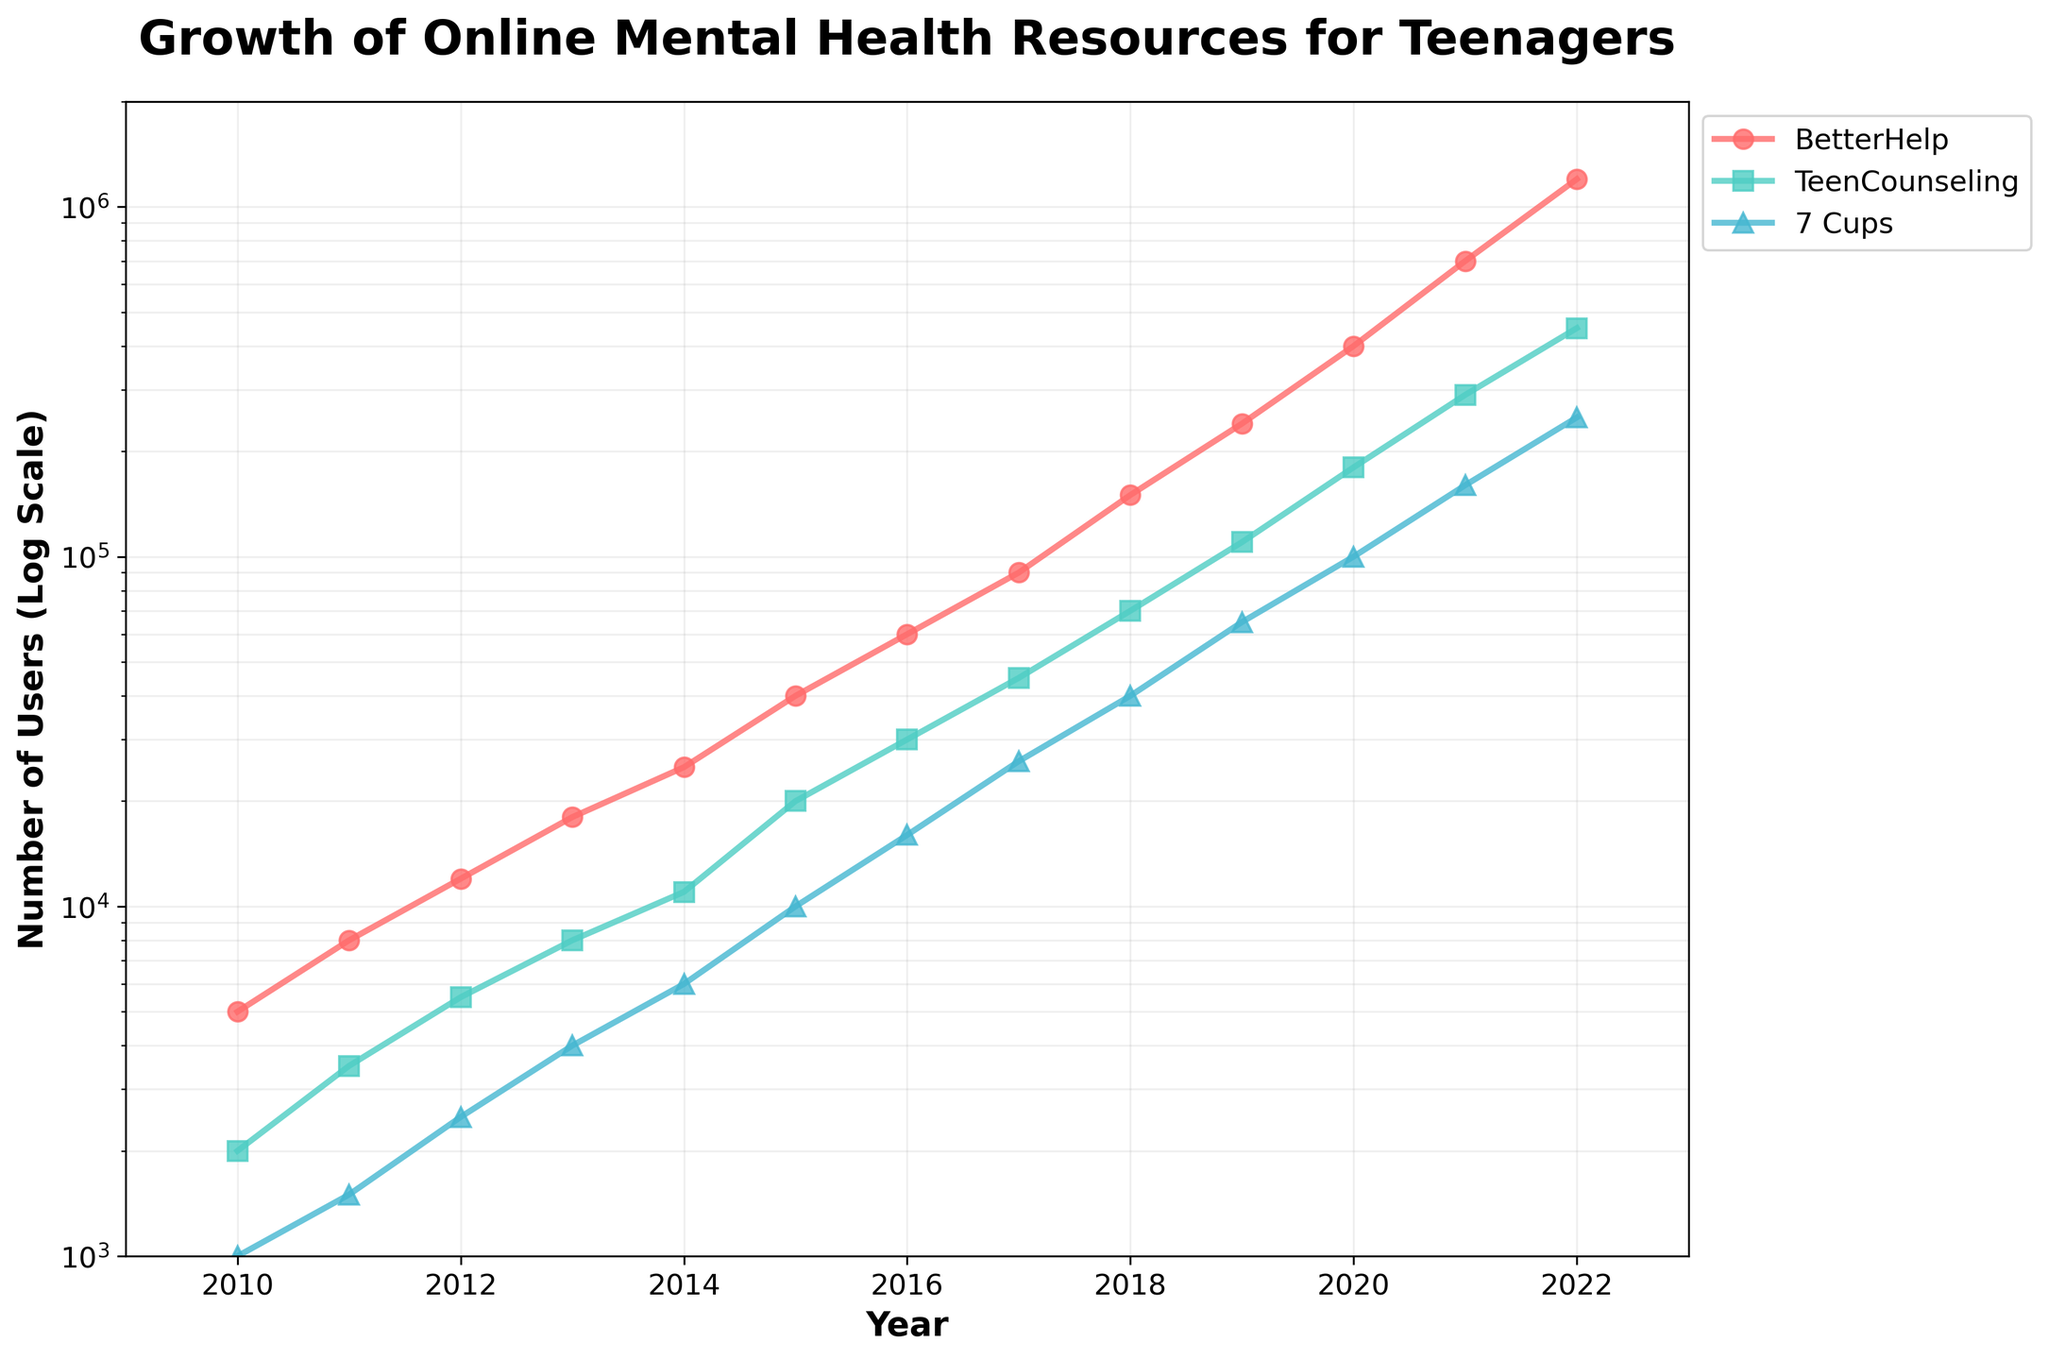What is the title of the plot? The title is located at the top of the figure. It provides a clear description of what the plot shows.
Answer: Growth of Online Mental Health Resources for Teenagers What is the y-axis scale used in the plot? Observing the y-axis, it is apparent that the values aren't evenly spaced. Instead, they increase exponentially, indicating a logarithmic scale.
Answer: Logarithmic scale Which resource had the greatest number of users in 2022? Locate the data points for 2022 on the x-axis and compare the y-values for each resource. The resource with the highest y-value in 2022 is the one with the greatest users.
Answer: BetterHelp How many users did 7 Cups have in 2010? Find 2010 on the x-axis and look at the y-value of the line corresponding to 7 Cups.
Answer: 1,000 What is the range of users for BetterHelp from 2010 to 2022? Determine the minimum and maximum user counts for BetterHelp within the given years and then calculate the difference. The minimum is 5,000 in 2010, and the maximum is 1,200,000 in 2022. Subtract the minimum from the maximum to find the range.
Answer: 1,195,000 Which resource shows the most rapid growth between 2010 and 2022? Analyze the slopes of the lines for each resource from 2010 to 2022. The resource with the steepest slope experienced the most rapid growth.
Answer: BetterHelp How does the number of users for TeenCounseling in 2015 compare to BetterHelp in 2015? Identify the data points for both resources in 2015 and compare their y-values. TeenCounseling has 20,000 users, and BetterHelp has 40,000 users. Therefore, BetterHelp has twice as many users.
Answer: BetterHelp has more users What is the average number of users for 7 Cups from 2010 to 2022? Add the user counts for 7 Cups for each year from 2010 to 2022 and then divide the sum by the number of years (13). User counts: 1,000, 1,500, 2,500, 4,000, 6,000, 10,000, 16,000, 26,000, 40,000, 65,000, 100,000, 160,000, 250,000. Sum is 681,000; average is 681,000 / 13.
Answer: 52,384.62 Between which consecutive years did TeenCounseling see the highest increase in users? Calculate the difference in users for TeenCounseling between each consecutive year and find the pair of years with the maximum difference.
Answer: 2021 and 2022 How many times more users did BetterHelp have in 2022 compared to 7 Cups in 2022? Find the user counts for BetterHelp and 7 Cups in 2022 (BetterHelp: 1,200,000; 7 Cups: 250,000) and then divide the two values.
Answer: BetterHelp had 4.8 times more users 